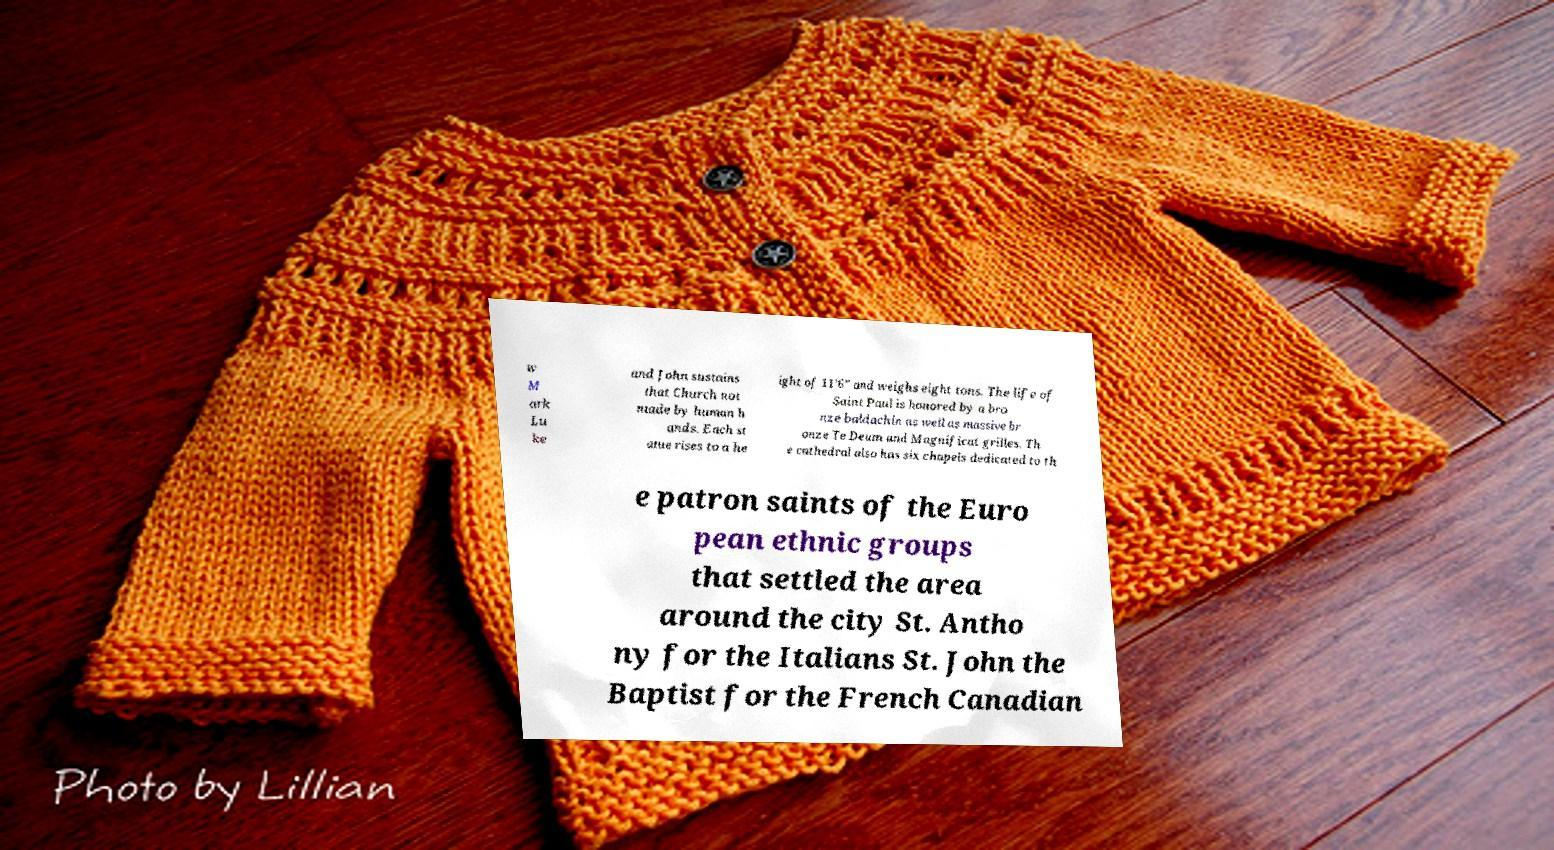For documentation purposes, I need the text within this image transcribed. Could you provide that? w M ark Lu ke and John sustains that Church not made by human h ands. Each st atue rises to a he ight of 11’6” and weighs eight tons. The life of Saint Paul is honored by a bro nze baldachin as well as massive br onze Te Deum and Magnificat grilles. Th e cathedral also has six chapels dedicated to th e patron saints of the Euro pean ethnic groups that settled the area around the city St. Antho ny for the Italians St. John the Baptist for the French Canadian 